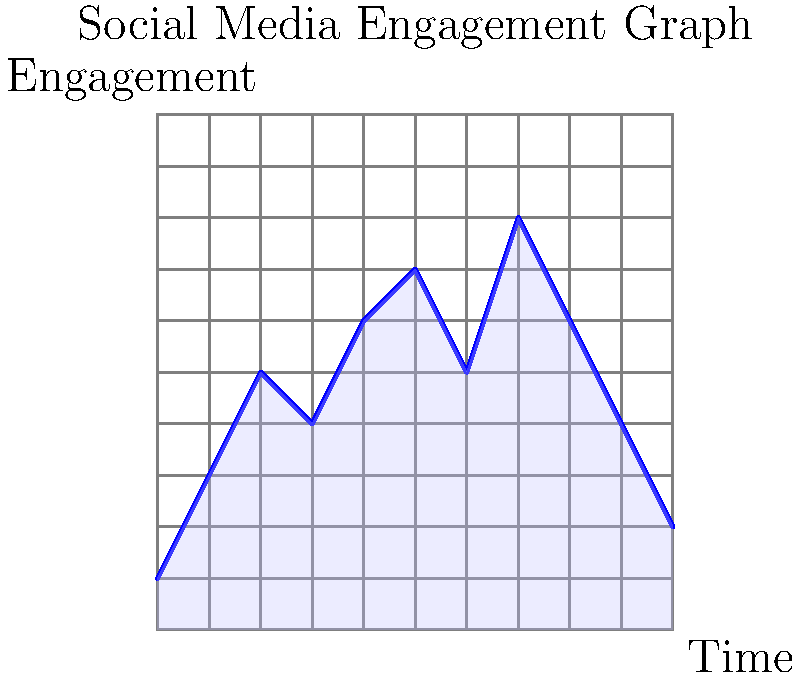As a social media marketing agency owner, you're analyzing a client's engagement graph over a 10-day period. The graph is overlaid on a grid where each square represents 100 engagements per day. Estimate the total number of engagements over the 10-day period by calculating the area under the curve. Round your answer to the nearest 100 engagements. To estimate the total number of engagements, we need to calculate the area under the curve using the grid method. Here's how to approach it:

1. Divide the area under the curve into full and partial squares.

2. Count the full squares:
   - There are approximately 32 full squares under the curve.

3. Estimate partial squares:
   - There are about 15 partial squares that, when combined, roughly equal 7.5 full squares.

4. Sum up the total number of squares:
   32 (full squares) + 7.5 (partial squares) = 39.5 squares

5. Calculate the total engagements:
   - Each square represents 100 engagements
   - Total engagements = 39.5 × 100 = 3,950 engagements

6. Round to the nearest 100:
   3,950 rounds to 4,000 engagements

Therefore, the estimated total number of engagements over the 10-day period is 4,000.
Answer: 4,000 engagements 